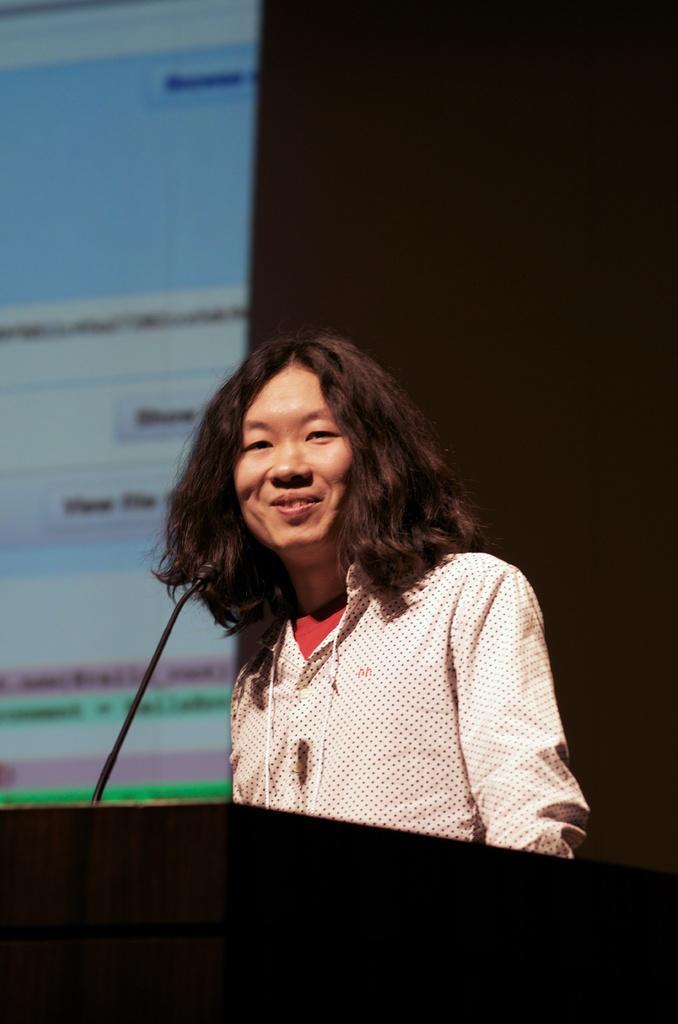How would you summarize this image in a sentence or two? In this picture we can see a woman talking in front of the mike, behind we can see projected screen. 